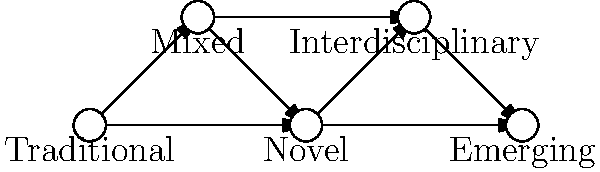In the network diagram of research methodologies, which approach serves as a bridge between traditional and novel methods, potentially facilitating the transition in your mentor's perspective? To answer this question, we need to analyze the network diagram of research methodologies:

1. The diagram shows five different research methodologies: Traditional, Mixed, Novel, Interdisciplinary, and Emerging.

2. These methodologies are represented as nodes in the network, interconnected by arrows indicating relationships or transitions between them.

3. The arrangement of nodes suggests a progression from left to right, with Traditional methods on the far left and Emerging methods on the far right.

4. We're looking for an approach that serves as a bridge between Traditional and Novel methods.

5. Examining the connections, we can see that the "Mixed" methodology is directly connected to both Traditional and Novel approaches.

6. The Mixed methodology occupies a central position between Traditional and Novel, suggesting it combines elements of both.

7. This positioning makes the Mixed methodology an ideal bridge for transitioning from Traditional to Novel approaches, as it incorporates aspects of both.

Therefore, the Mixed methodology serves as the bridge between Traditional and Novel methods, potentially helping to ease your mentor's transition towards embracing novel research methodologies.
Answer: Mixed methodology 